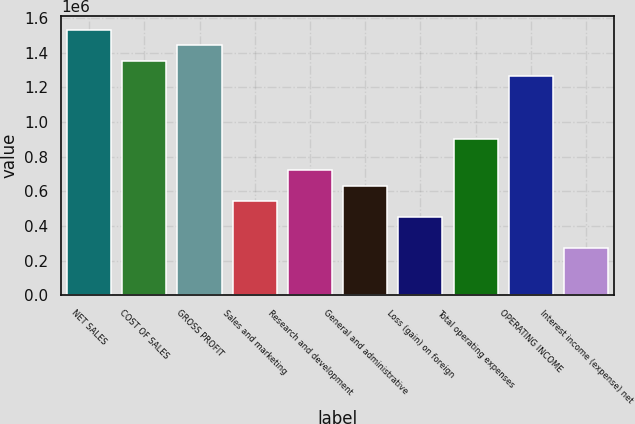Convert chart. <chart><loc_0><loc_0><loc_500><loc_500><bar_chart><fcel>NET SALES<fcel>COST OF SALES<fcel>GROSS PROFIT<fcel>Sales and marketing<fcel>Research and development<fcel>General and administrative<fcel>Loss (gain) on foreign<fcel>Total operating expenses<fcel>OPERATING INCOME<fcel>Interest income (expense) net<nl><fcel>1.53215e+06<fcel>1.3519e+06<fcel>1.44202e+06<fcel>540761<fcel>721013<fcel>630887<fcel>450635<fcel>901265<fcel>1.26177e+06<fcel>270383<nl></chart> 